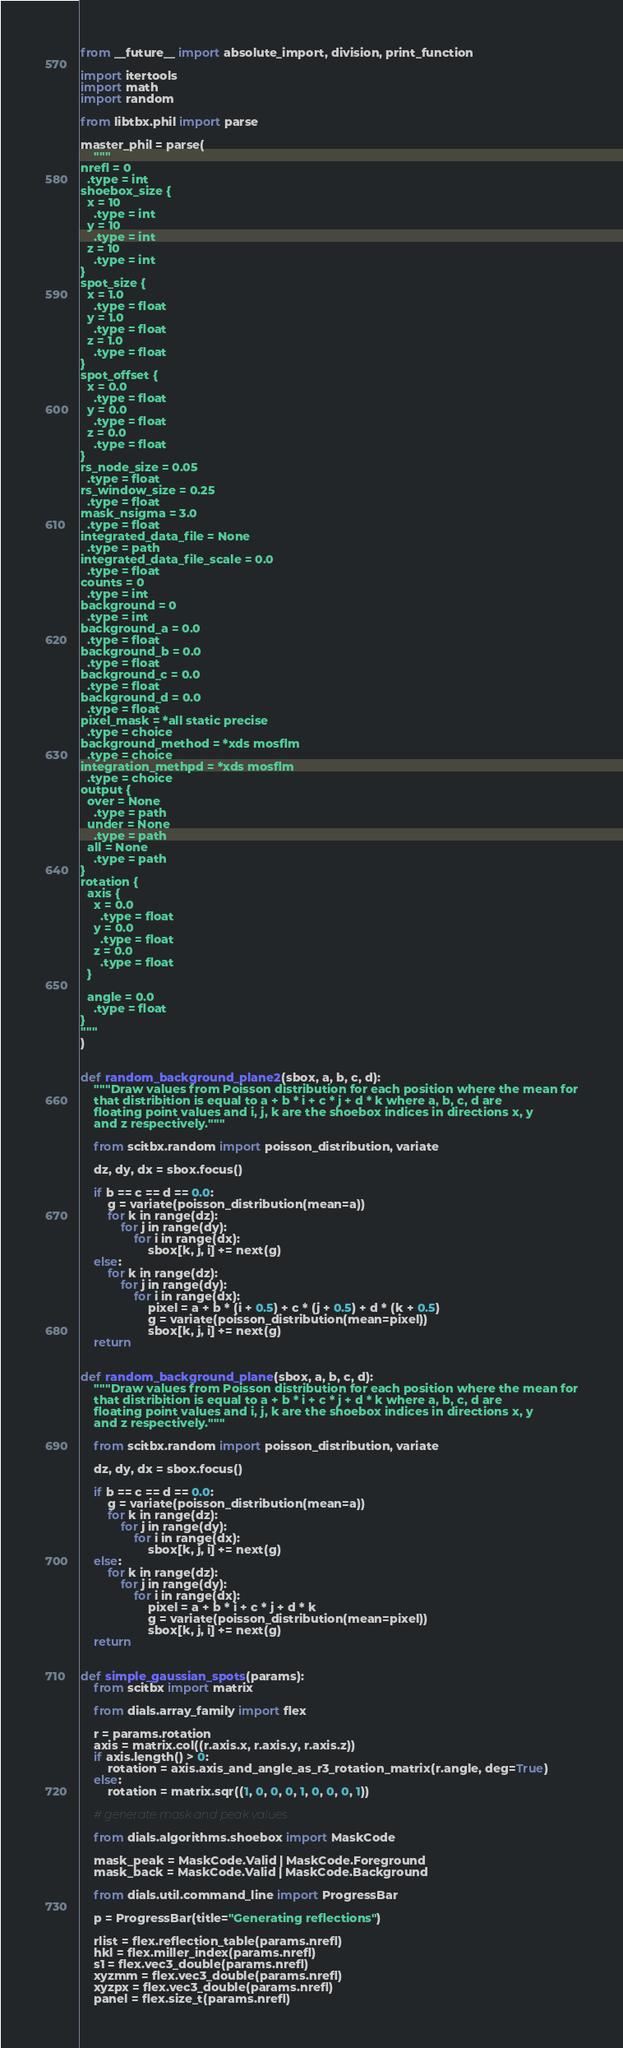Convert code to text. <code><loc_0><loc_0><loc_500><loc_500><_Python_>from __future__ import absolute_import, division, print_function

import itertools
import math
import random

from libtbx.phil import parse

master_phil = parse(
    """
nrefl = 0
  .type = int
shoebox_size {
  x = 10
    .type = int
  y = 10
    .type = int
  z = 10
    .type = int
}
spot_size {
  x = 1.0
    .type = float
  y = 1.0
    .type = float
  z = 1.0
    .type = float
}
spot_offset {
  x = 0.0
    .type = float
  y = 0.0
    .type = float
  z = 0.0
    .type = float
}
rs_node_size = 0.05
  .type = float
rs_window_size = 0.25
  .type = float
mask_nsigma = 3.0
  .type = float
integrated_data_file = None
  .type = path
integrated_data_file_scale = 0.0
  .type = float
counts = 0
  .type = int
background = 0
  .type = int
background_a = 0.0
  .type = float
background_b = 0.0
  .type = float
background_c = 0.0
  .type = float
background_d = 0.0
  .type = float
pixel_mask = *all static precise
  .type = choice
background_method = *xds mosflm
  .type = choice
integration_methpd = *xds mosflm
  .type = choice
output {
  over = None
    .type = path
  under = None
    .type = path
  all = None
    .type = path
}
rotation {
  axis {
    x = 0.0
      .type = float
    y = 0.0
      .type = float
    z = 0.0
      .type = float
  }

  angle = 0.0
    .type = float
}
"""
)


def random_background_plane2(sbox, a, b, c, d):
    """Draw values from Poisson distribution for each position where the mean for
    that distribition is equal to a + b * i + c * j + d * k where a, b, c, d are
    floating point values and i, j, k are the shoebox indices in directions x, y
    and z respectively."""

    from scitbx.random import poisson_distribution, variate

    dz, dy, dx = sbox.focus()

    if b == c == d == 0.0:
        g = variate(poisson_distribution(mean=a))
        for k in range(dz):
            for j in range(dy):
                for i in range(dx):
                    sbox[k, j, i] += next(g)
    else:
        for k in range(dz):
            for j in range(dy):
                for i in range(dx):
                    pixel = a + b * (i + 0.5) + c * (j + 0.5) + d * (k + 0.5)
                    g = variate(poisson_distribution(mean=pixel))
                    sbox[k, j, i] += next(g)
    return


def random_background_plane(sbox, a, b, c, d):
    """Draw values from Poisson distribution for each position where the mean for
    that distribition is equal to a + b * i + c * j + d * k where a, b, c, d are
    floating point values and i, j, k are the shoebox indices in directions x, y
    and z respectively."""

    from scitbx.random import poisson_distribution, variate

    dz, dy, dx = sbox.focus()

    if b == c == d == 0.0:
        g = variate(poisson_distribution(mean=a))
        for k in range(dz):
            for j in range(dy):
                for i in range(dx):
                    sbox[k, j, i] += next(g)
    else:
        for k in range(dz):
            for j in range(dy):
                for i in range(dx):
                    pixel = a + b * i + c * j + d * k
                    g = variate(poisson_distribution(mean=pixel))
                    sbox[k, j, i] += next(g)
    return


def simple_gaussian_spots(params):
    from scitbx import matrix

    from dials.array_family import flex

    r = params.rotation
    axis = matrix.col((r.axis.x, r.axis.y, r.axis.z))
    if axis.length() > 0:
        rotation = axis.axis_and_angle_as_r3_rotation_matrix(r.angle, deg=True)
    else:
        rotation = matrix.sqr((1, 0, 0, 0, 1, 0, 0, 0, 1))

    # generate mask and peak values

    from dials.algorithms.shoebox import MaskCode

    mask_peak = MaskCode.Valid | MaskCode.Foreground
    mask_back = MaskCode.Valid | MaskCode.Background

    from dials.util.command_line import ProgressBar

    p = ProgressBar(title="Generating reflections")

    rlist = flex.reflection_table(params.nrefl)
    hkl = flex.miller_index(params.nrefl)
    s1 = flex.vec3_double(params.nrefl)
    xyzmm = flex.vec3_double(params.nrefl)
    xyzpx = flex.vec3_double(params.nrefl)
    panel = flex.size_t(params.nrefl)</code> 